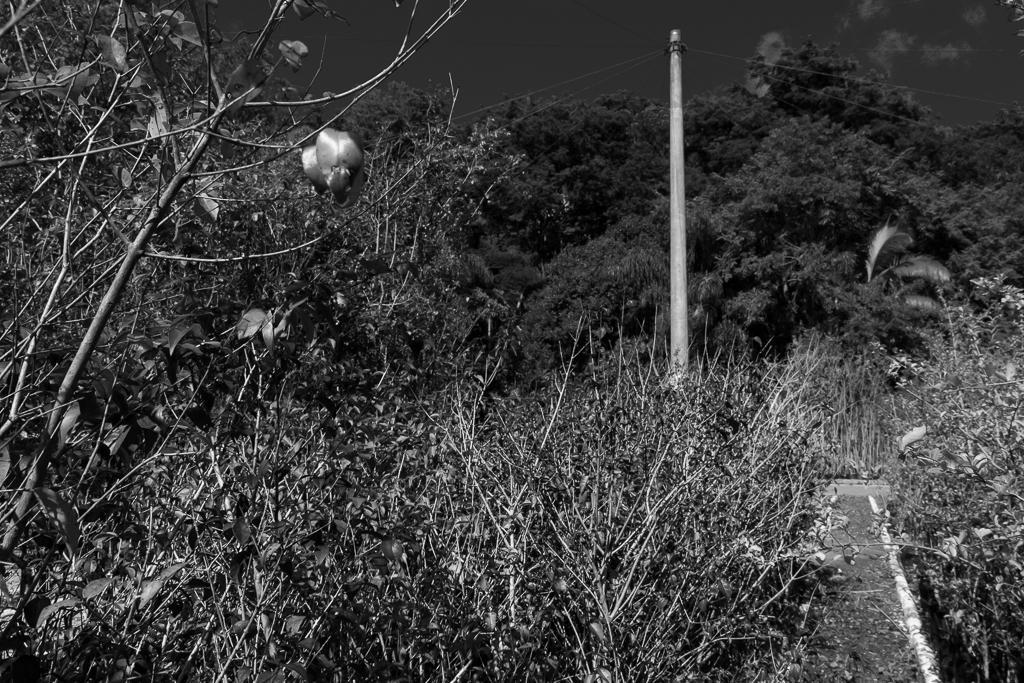Please provide a concise description of this image. This is a black and white image we can see there are some trees at the bottom of this image and there is a sky at the top of this image. There is a pole on the right side of this image. 